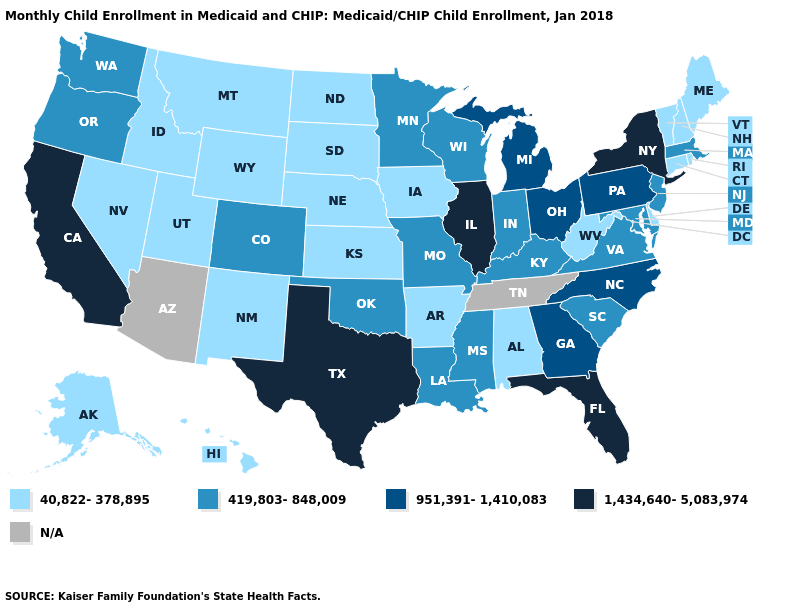What is the value of Tennessee?
Write a very short answer. N/A. Does North Dakota have the highest value in the USA?
Concise answer only. No. Name the states that have a value in the range 419,803-848,009?
Write a very short answer. Colorado, Indiana, Kentucky, Louisiana, Maryland, Massachusetts, Minnesota, Mississippi, Missouri, New Jersey, Oklahoma, Oregon, South Carolina, Virginia, Washington, Wisconsin. What is the highest value in states that border Indiana?
Keep it brief. 1,434,640-5,083,974. What is the lowest value in the USA?
Quick response, please. 40,822-378,895. How many symbols are there in the legend?
Short answer required. 5. Does the map have missing data?
Concise answer only. Yes. How many symbols are there in the legend?
Give a very brief answer. 5. Does Nevada have the lowest value in the West?
Give a very brief answer. Yes. Among the states that border Minnesota , which have the highest value?
Short answer required. Wisconsin. Among the states that border Colorado , does Kansas have the lowest value?
Short answer required. Yes. Among the states that border Michigan , which have the lowest value?
Write a very short answer. Indiana, Wisconsin. How many symbols are there in the legend?
Be succinct. 5. 